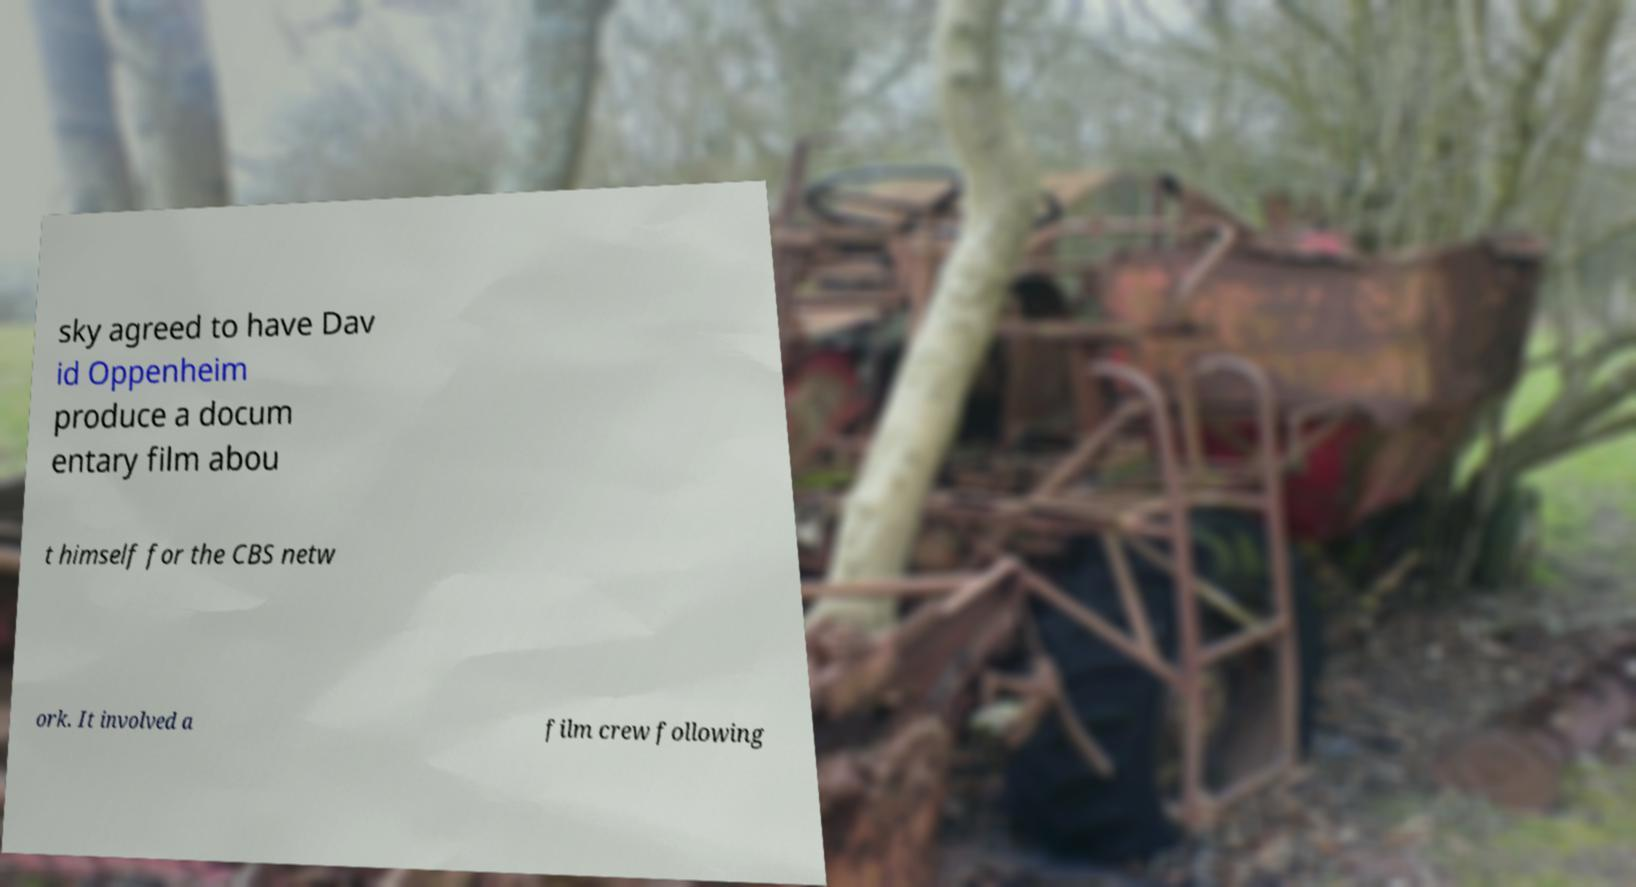Can you read and provide the text displayed in the image?This photo seems to have some interesting text. Can you extract and type it out for me? sky agreed to have Dav id Oppenheim produce a docum entary film abou t himself for the CBS netw ork. It involved a film crew following 